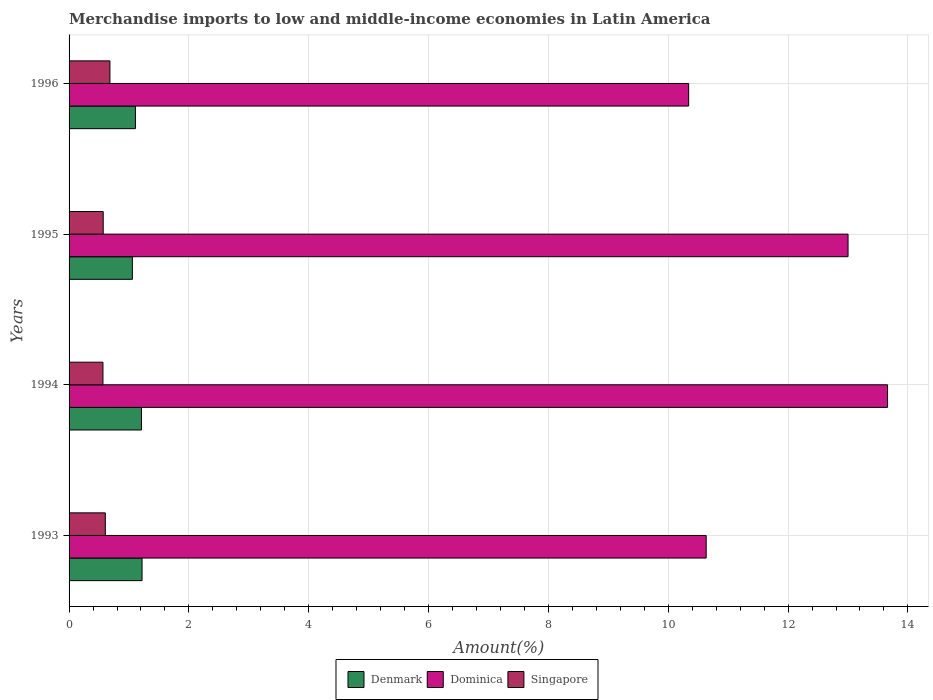How many different coloured bars are there?
Your response must be concise. 3. Are the number of bars on each tick of the Y-axis equal?
Your answer should be compact. Yes. How many bars are there on the 3rd tick from the top?
Ensure brevity in your answer.  3. What is the label of the 3rd group of bars from the top?
Make the answer very short. 1994. In how many cases, is the number of bars for a given year not equal to the number of legend labels?
Keep it short and to the point. 0. What is the percentage of amount earned from merchandise imports in Denmark in 1995?
Provide a succinct answer. 1.06. Across all years, what is the maximum percentage of amount earned from merchandise imports in Denmark?
Offer a very short reply. 1.22. Across all years, what is the minimum percentage of amount earned from merchandise imports in Dominica?
Offer a terse response. 10.34. In which year was the percentage of amount earned from merchandise imports in Dominica maximum?
Keep it short and to the point. 1994. What is the total percentage of amount earned from merchandise imports in Singapore in the graph?
Offer a very short reply. 2.42. What is the difference between the percentage of amount earned from merchandise imports in Singapore in 1993 and that in 1994?
Keep it short and to the point. 0.04. What is the difference between the percentage of amount earned from merchandise imports in Denmark in 1994 and the percentage of amount earned from merchandise imports in Singapore in 1993?
Your answer should be very brief. 0.6. What is the average percentage of amount earned from merchandise imports in Singapore per year?
Give a very brief answer. 0.61. In the year 1994, what is the difference between the percentage of amount earned from merchandise imports in Denmark and percentage of amount earned from merchandise imports in Dominica?
Your answer should be very brief. -12.45. In how many years, is the percentage of amount earned from merchandise imports in Denmark greater than 7.6 %?
Your answer should be compact. 0. What is the ratio of the percentage of amount earned from merchandise imports in Denmark in 1994 to that in 1995?
Make the answer very short. 1.14. Is the percentage of amount earned from merchandise imports in Dominica in 1993 less than that in 1996?
Ensure brevity in your answer.  No. What is the difference between the highest and the second highest percentage of amount earned from merchandise imports in Denmark?
Offer a terse response. 0.01. What is the difference between the highest and the lowest percentage of amount earned from merchandise imports in Dominica?
Give a very brief answer. 3.32. In how many years, is the percentage of amount earned from merchandise imports in Singapore greater than the average percentage of amount earned from merchandise imports in Singapore taken over all years?
Your answer should be compact. 1. What does the 1st bar from the top in 1994 represents?
Offer a very short reply. Singapore. What does the 3rd bar from the bottom in 1994 represents?
Your answer should be very brief. Singapore. How many bars are there?
Offer a terse response. 12. Are all the bars in the graph horizontal?
Your response must be concise. Yes. What is the difference between two consecutive major ticks on the X-axis?
Offer a terse response. 2. Are the values on the major ticks of X-axis written in scientific E-notation?
Give a very brief answer. No. Does the graph contain any zero values?
Provide a succinct answer. No. How many legend labels are there?
Provide a succinct answer. 3. How are the legend labels stacked?
Offer a terse response. Horizontal. What is the title of the graph?
Your response must be concise. Merchandise imports to low and middle-income economies in Latin America. What is the label or title of the X-axis?
Your answer should be compact. Amount(%). What is the label or title of the Y-axis?
Offer a very short reply. Years. What is the Amount(%) in Denmark in 1993?
Offer a very short reply. 1.22. What is the Amount(%) of Dominica in 1993?
Offer a terse response. 10.63. What is the Amount(%) in Singapore in 1993?
Your answer should be very brief. 0.6. What is the Amount(%) of Denmark in 1994?
Provide a succinct answer. 1.21. What is the Amount(%) in Dominica in 1994?
Give a very brief answer. 13.66. What is the Amount(%) in Singapore in 1994?
Provide a succinct answer. 0.57. What is the Amount(%) of Denmark in 1995?
Provide a short and direct response. 1.06. What is the Amount(%) in Dominica in 1995?
Offer a terse response. 13. What is the Amount(%) in Singapore in 1995?
Make the answer very short. 0.57. What is the Amount(%) of Denmark in 1996?
Your response must be concise. 1.11. What is the Amount(%) of Dominica in 1996?
Give a very brief answer. 10.34. What is the Amount(%) in Singapore in 1996?
Offer a terse response. 0.68. Across all years, what is the maximum Amount(%) of Denmark?
Offer a terse response. 1.22. Across all years, what is the maximum Amount(%) in Dominica?
Keep it short and to the point. 13.66. Across all years, what is the maximum Amount(%) of Singapore?
Offer a terse response. 0.68. Across all years, what is the minimum Amount(%) of Denmark?
Offer a terse response. 1.06. Across all years, what is the minimum Amount(%) in Dominica?
Offer a very short reply. 10.34. Across all years, what is the minimum Amount(%) of Singapore?
Ensure brevity in your answer.  0.57. What is the total Amount(%) in Denmark in the graph?
Your response must be concise. 4.59. What is the total Amount(%) of Dominica in the graph?
Ensure brevity in your answer.  47.64. What is the total Amount(%) in Singapore in the graph?
Offer a very short reply. 2.42. What is the difference between the Amount(%) of Denmark in 1993 and that in 1994?
Your answer should be compact. 0.01. What is the difference between the Amount(%) of Dominica in 1993 and that in 1994?
Give a very brief answer. -3.03. What is the difference between the Amount(%) of Singapore in 1993 and that in 1994?
Offer a very short reply. 0.04. What is the difference between the Amount(%) of Denmark in 1993 and that in 1995?
Your response must be concise. 0.16. What is the difference between the Amount(%) of Dominica in 1993 and that in 1995?
Your answer should be very brief. -2.37. What is the difference between the Amount(%) of Singapore in 1993 and that in 1995?
Provide a succinct answer. 0.04. What is the difference between the Amount(%) of Denmark in 1993 and that in 1996?
Ensure brevity in your answer.  0.11. What is the difference between the Amount(%) in Dominica in 1993 and that in 1996?
Your answer should be very brief. 0.29. What is the difference between the Amount(%) in Singapore in 1993 and that in 1996?
Provide a short and direct response. -0.08. What is the difference between the Amount(%) in Denmark in 1994 and that in 1995?
Your answer should be very brief. 0.15. What is the difference between the Amount(%) of Dominica in 1994 and that in 1995?
Keep it short and to the point. 0.66. What is the difference between the Amount(%) of Singapore in 1994 and that in 1995?
Your answer should be very brief. -0. What is the difference between the Amount(%) in Denmark in 1994 and that in 1996?
Your answer should be compact. 0.1. What is the difference between the Amount(%) of Dominica in 1994 and that in 1996?
Ensure brevity in your answer.  3.32. What is the difference between the Amount(%) of Singapore in 1994 and that in 1996?
Provide a succinct answer. -0.12. What is the difference between the Amount(%) in Denmark in 1995 and that in 1996?
Your answer should be very brief. -0.05. What is the difference between the Amount(%) in Dominica in 1995 and that in 1996?
Provide a succinct answer. 2.66. What is the difference between the Amount(%) of Singapore in 1995 and that in 1996?
Offer a very short reply. -0.11. What is the difference between the Amount(%) in Denmark in 1993 and the Amount(%) in Dominica in 1994?
Offer a very short reply. -12.44. What is the difference between the Amount(%) of Denmark in 1993 and the Amount(%) of Singapore in 1994?
Offer a terse response. 0.65. What is the difference between the Amount(%) in Dominica in 1993 and the Amount(%) in Singapore in 1994?
Your answer should be compact. 10.07. What is the difference between the Amount(%) of Denmark in 1993 and the Amount(%) of Dominica in 1995?
Make the answer very short. -11.78. What is the difference between the Amount(%) in Denmark in 1993 and the Amount(%) in Singapore in 1995?
Offer a very short reply. 0.65. What is the difference between the Amount(%) in Dominica in 1993 and the Amount(%) in Singapore in 1995?
Give a very brief answer. 10.06. What is the difference between the Amount(%) of Denmark in 1993 and the Amount(%) of Dominica in 1996?
Your answer should be compact. -9.12. What is the difference between the Amount(%) of Denmark in 1993 and the Amount(%) of Singapore in 1996?
Your answer should be very brief. 0.54. What is the difference between the Amount(%) of Dominica in 1993 and the Amount(%) of Singapore in 1996?
Your answer should be compact. 9.95. What is the difference between the Amount(%) in Denmark in 1994 and the Amount(%) in Dominica in 1995?
Offer a terse response. -11.79. What is the difference between the Amount(%) in Denmark in 1994 and the Amount(%) in Singapore in 1995?
Provide a succinct answer. 0.64. What is the difference between the Amount(%) in Dominica in 1994 and the Amount(%) in Singapore in 1995?
Provide a short and direct response. 13.09. What is the difference between the Amount(%) in Denmark in 1994 and the Amount(%) in Dominica in 1996?
Ensure brevity in your answer.  -9.13. What is the difference between the Amount(%) of Denmark in 1994 and the Amount(%) of Singapore in 1996?
Your answer should be very brief. 0.53. What is the difference between the Amount(%) in Dominica in 1994 and the Amount(%) in Singapore in 1996?
Provide a succinct answer. 12.98. What is the difference between the Amount(%) in Denmark in 1995 and the Amount(%) in Dominica in 1996?
Keep it short and to the point. -9.28. What is the difference between the Amount(%) in Dominica in 1995 and the Amount(%) in Singapore in 1996?
Offer a very short reply. 12.32. What is the average Amount(%) of Denmark per year?
Ensure brevity in your answer.  1.15. What is the average Amount(%) of Dominica per year?
Your answer should be compact. 11.91. What is the average Amount(%) in Singapore per year?
Provide a succinct answer. 0.61. In the year 1993, what is the difference between the Amount(%) of Denmark and Amount(%) of Dominica?
Provide a short and direct response. -9.42. In the year 1993, what is the difference between the Amount(%) of Denmark and Amount(%) of Singapore?
Your response must be concise. 0.61. In the year 1993, what is the difference between the Amount(%) of Dominica and Amount(%) of Singapore?
Your answer should be very brief. 10.03. In the year 1994, what is the difference between the Amount(%) in Denmark and Amount(%) in Dominica?
Keep it short and to the point. -12.45. In the year 1994, what is the difference between the Amount(%) of Denmark and Amount(%) of Singapore?
Make the answer very short. 0.64. In the year 1994, what is the difference between the Amount(%) in Dominica and Amount(%) in Singapore?
Provide a short and direct response. 13.1. In the year 1995, what is the difference between the Amount(%) in Denmark and Amount(%) in Dominica?
Offer a terse response. -11.94. In the year 1995, what is the difference between the Amount(%) in Denmark and Amount(%) in Singapore?
Give a very brief answer. 0.49. In the year 1995, what is the difference between the Amount(%) in Dominica and Amount(%) in Singapore?
Give a very brief answer. 12.43. In the year 1996, what is the difference between the Amount(%) in Denmark and Amount(%) in Dominica?
Offer a very short reply. -9.23. In the year 1996, what is the difference between the Amount(%) in Denmark and Amount(%) in Singapore?
Your answer should be compact. 0.43. In the year 1996, what is the difference between the Amount(%) in Dominica and Amount(%) in Singapore?
Give a very brief answer. 9.66. What is the ratio of the Amount(%) in Denmark in 1993 to that in 1994?
Give a very brief answer. 1.01. What is the ratio of the Amount(%) in Dominica in 1993 to that in 1994?
Provide a succinct answer. 0.78. What is the ratio of the Amount(%) of Singapore in 1993 to that in 1994?
Offer a terse response. 1.07. What is the ratio of the Amount(%) in Denmark in 1993 to that in 1995?
Offer a terse response. 1.15. What is the ratio of the Amount(%) in Dominica in 1993 to that in 1995?
Offer a very short reply. 0.82. What is the ratio of the Amount(%) of Singapore in 1993 to that in 1995?
Your answer should be very brief. 1.06. What is the ratio of the Amount(%) of Denmark in 1993 to that in 1996?
Offer a terse response. 1.1. What is the ratio of the Amount(%) of Dominica in 1993 to that in 1996?
Offer a very short reply. 1.03. What is the ratio of the Amount(%) in Singapore in 1993 to that in 1996?
Your answer should be compact. 0.89. What is the ratio of the Amount(%) of Denmark in 1994 to that in 1995?
Provide a succinct answer. 1.14. What is the ratio of the Amount(%) of Dominica in 1994 to that in 1995?
Your answer should be very brief. 1.05. What is the ratio of the Amount(%) of Singapore in 1994 to that in 1995?
Keep it short and to the point. 0.99. What is the ratio of the Amount(%) in Denmark in 1994 to that in 1996?
Ensure brevity in your answer.  1.09. What is the ratio of the Amount(%) of Dominica in 1994 to that in 1996?
Ensure brevity in your answer.  1.32. What is the ratio of the Amount(%) in Singapore in 1994 to that in 1996?
Offer a terse response. 0.83. What is the ratio of the Amount(%) in Denmark in 1995 to that in 1996?
Provide a succinct answer. 0.95. What is the ratio of the Amount(%) in Dominica in 1995 to that in 1996?
Make the answer very short. 1.26. What is the ratio of the Amount(%) of Singapore in 1995 to that in 1996?
Provide a short and direct response. 0.84. What is the difference between the highest and the second highest Amount(%) in Denmark?
Keep it short and to the point. 0.01. What is the difference between the highest and the second highest Amount(%) in Dominica?
Keep it short and to the point. 0.66. What is the difference between the highest and the second highest Amount(%) in Singapore?
Your answer should be compact. 0.08. What is the difference between the highest and the lowest Amount(%) of Denmark?
Make the answer very short. 0.16. What is the difference between the highest and the lowest Amount(%) in Dominica?
Your response must be concise. 3.32. What is the difference between the highest and the lowest Amount(%) of Singapore?
Provide a succinct answer. 0.12. 